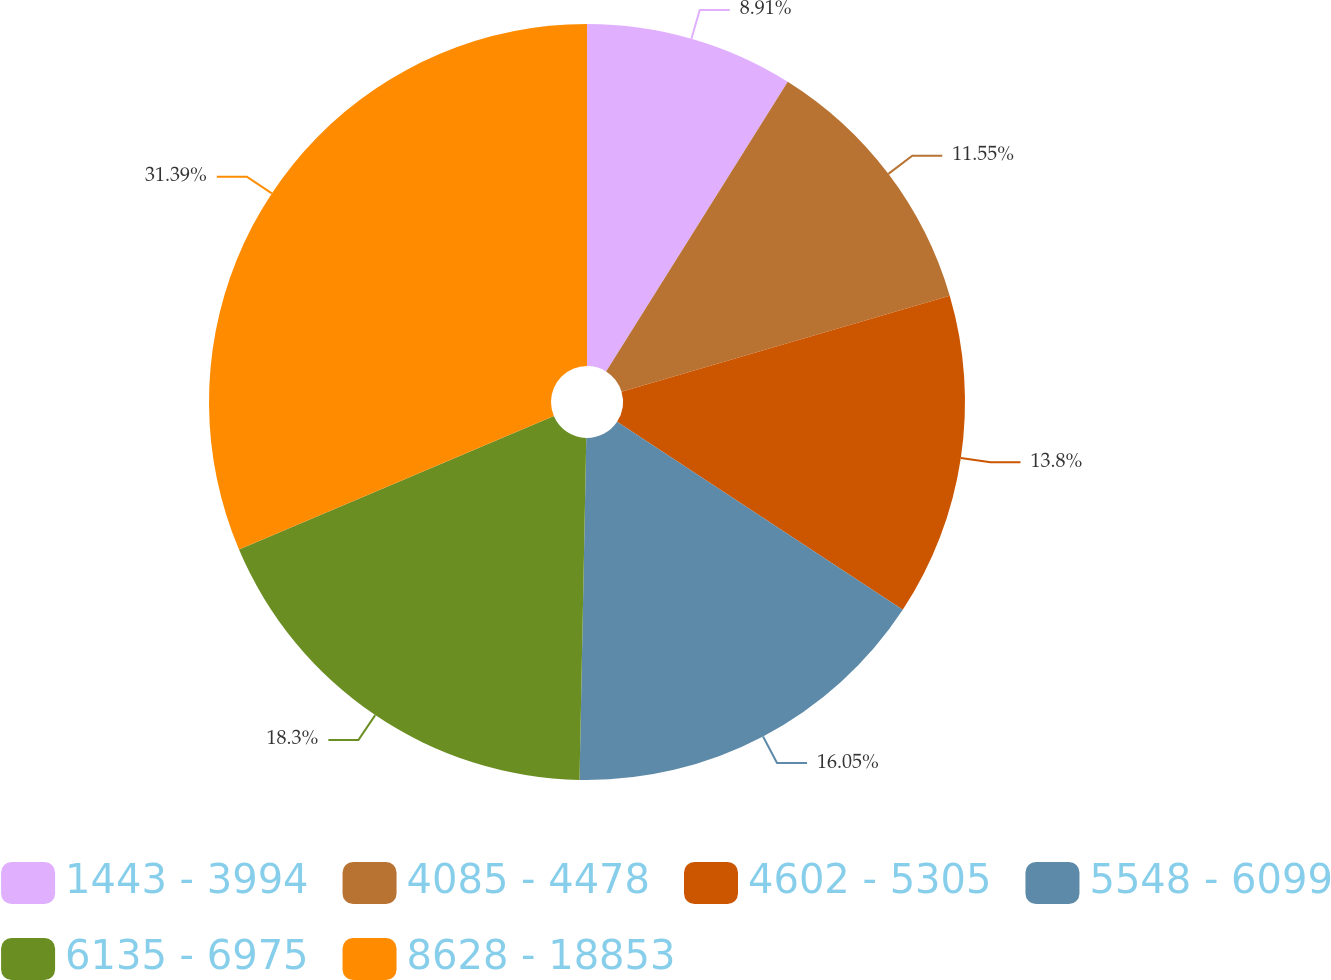<chart> <loc_0><loc_0><loc_500><loc_500><pie_chart><fcel>1443 - 3994<fcel>4085 - 4478<fcel>4602 - 5305<fcel>5548 - 6099<fcel>6135 - 6975<fcel>8628 - 18853<nl><fcel>8.91%<fcel>11.55%<fcel>13.8%<fcel>16.05%<fcel>18.3%<fcel>31.38%<nl></chart> 